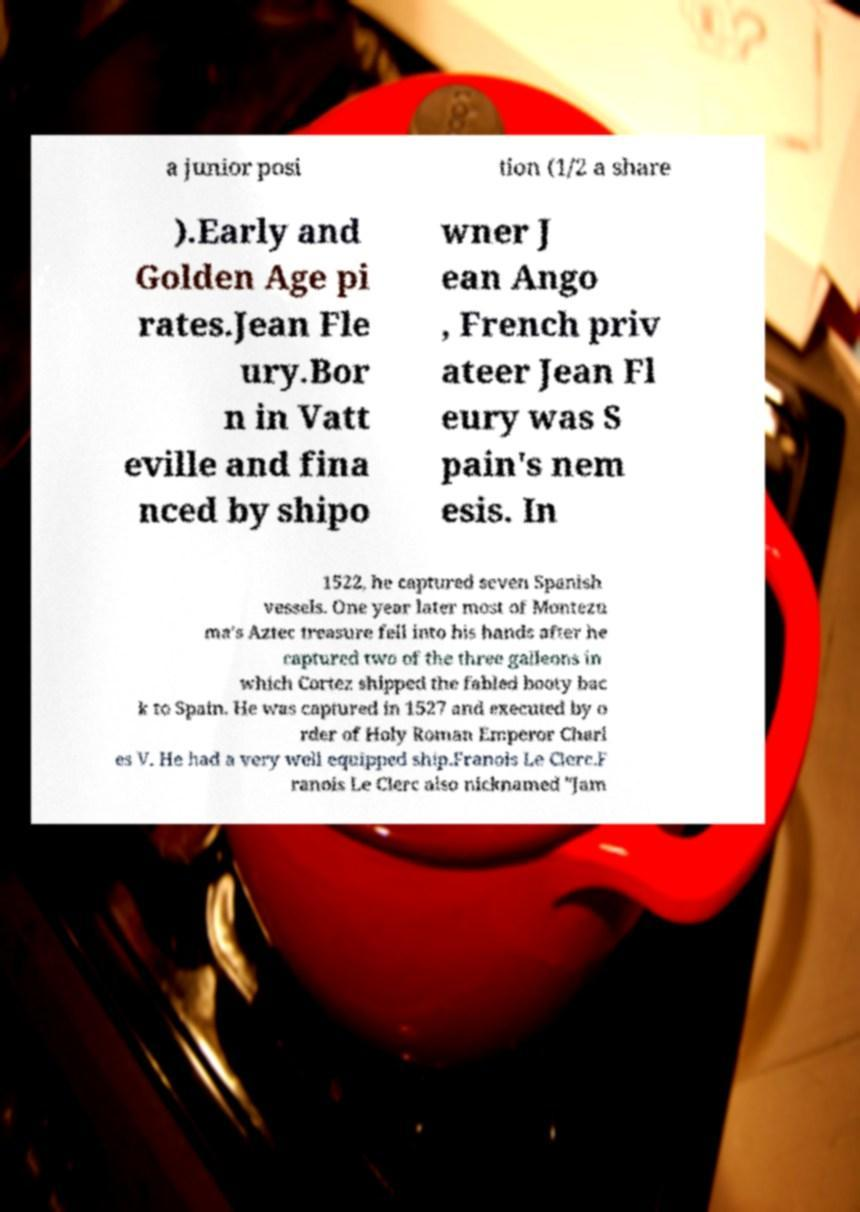Please identify and transcribe the text found in this image. a junior posi tion (1/2 a share ).Early and Golden Age pi rates.Jean Fle ury.Bor n in Vatt eville and fina nced by shipo wner J ean Ango , French priv ateer Jean Fl eury was S pain's nem esis. In 1522, he captured seven Spanish vessels. One year later most of Montezu ma's Aztec treasure fell into his hands after he captured two of the three galleons in which Cortez shipped the fabled booty bac k to Spain. He was captured in 1527 and executed by o rder of Holy Roman Emperor Charl es V. He had a very well equipped ship.Franois Le Clerc.F ranois Le Clerc also nicknamed "Jam 